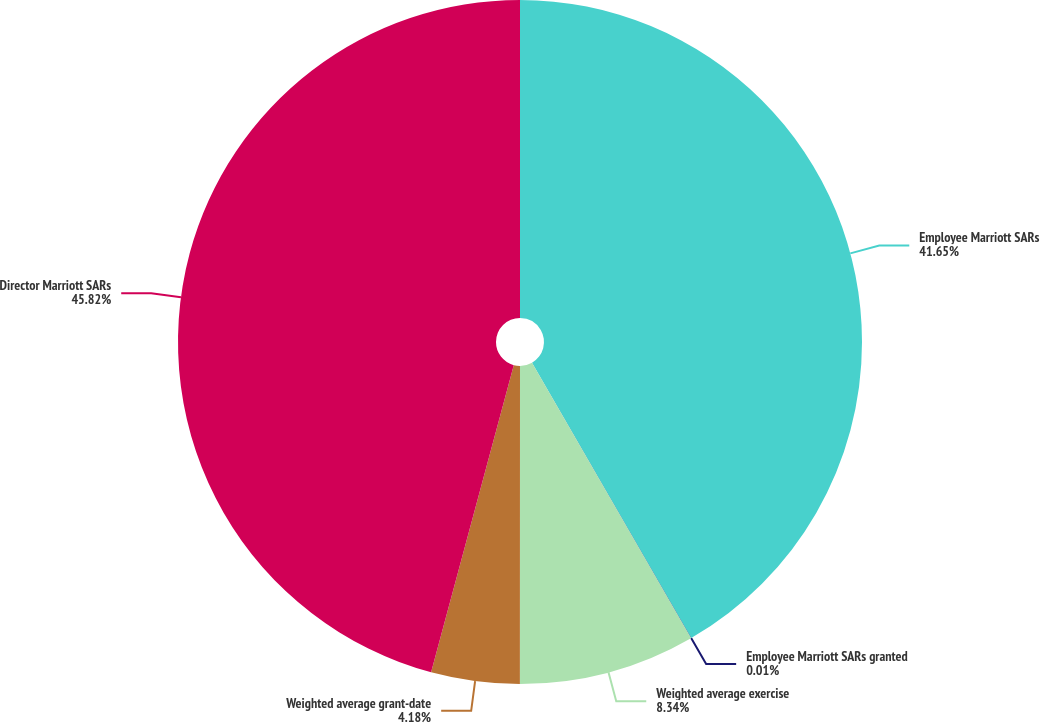Convert chart. <chart><loc_0><loc_0><loc_500><loc_500><pie_chart><fcel>Employee Marriott SARs<fcel>Employee Marriott SARs granted<fcel>Weighted average exercise<fcel>Weighted average grant-date<fcel>Director Marriott SARs<nl><fcel>41.65%<fcel>0.01%<fcel>8.34%<fcel>4.18%<fcel>45.81%<nl></chart> 